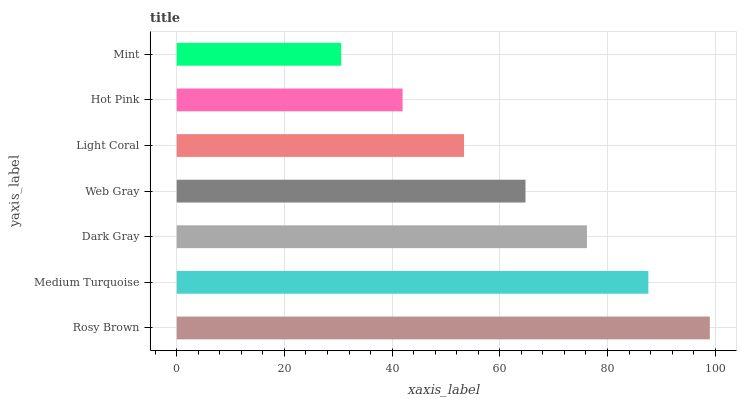Is Mint the minimum?
Answer yes or no. Yes. Is Rosy Brown the maximum?
Answer yes or no. Yes. Is Medium Turquoise the minimum?
Answer yes or no. No. Is Medium Turquoise the maximum?
Answer yes or no. No. Is Rosy Brown greater than Medium Turquoise?
Answer yes or no. Yes. Is Medium Turquoise less than Rosy Brown?
Answer yes or no. Yes. Is Medium Turquoise greater than Rosy Brown?
Answer yes or no. No. Is Rosy Brown less than Medium Turquoise?
Answer yes or no. No. Is Web Gray the high median?
Answer yes or no. Yes. Is Web Gray the low median?
Answer yes or no. Yes. Is Medium Turquoise the high median?
Answer yes or no. No. Is Dark Gray the low median?
Answer yes or no. No. 